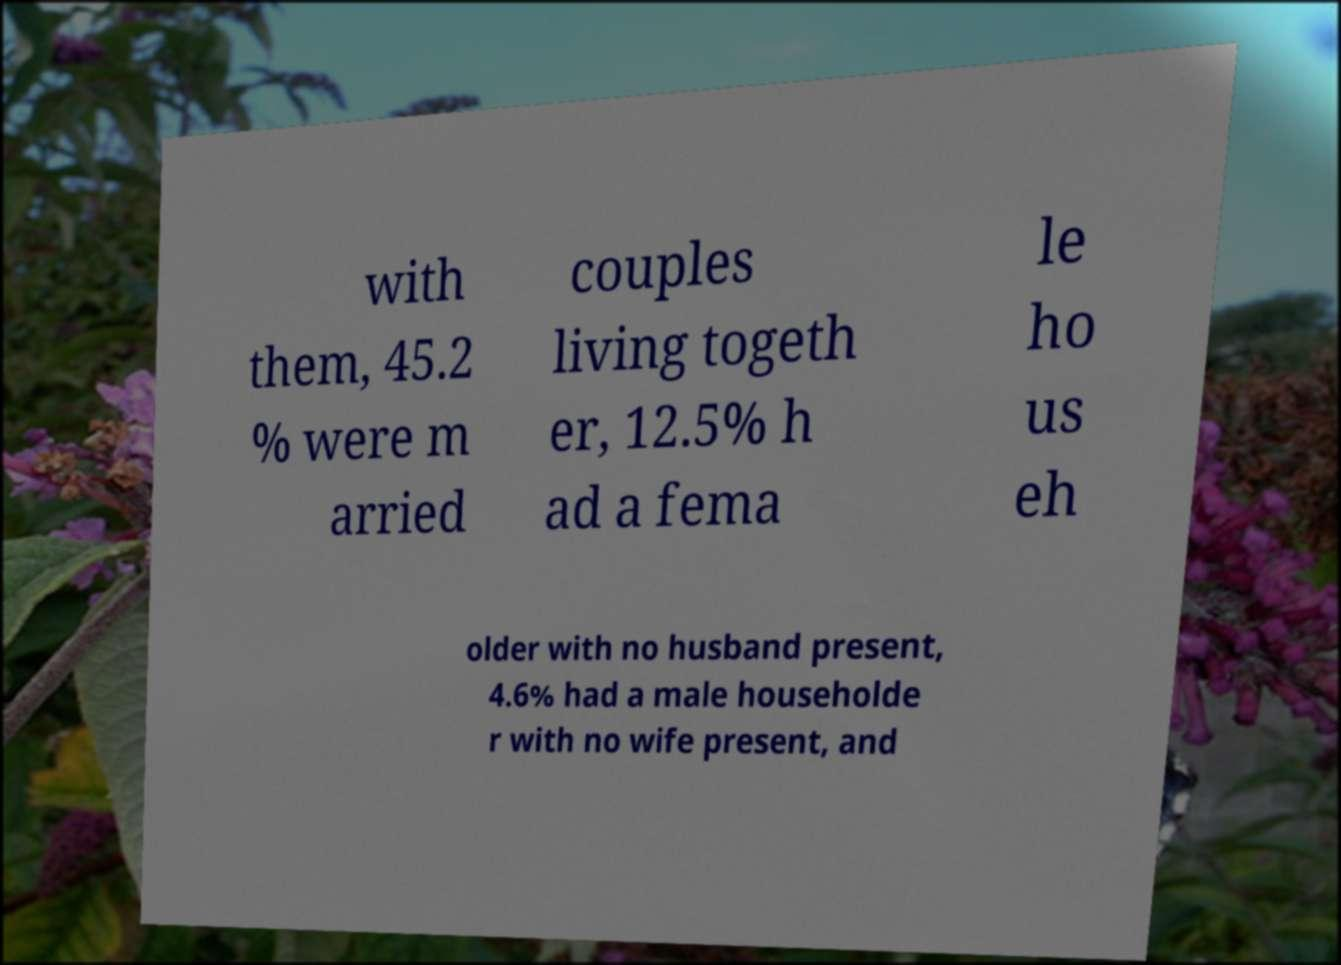What messages or text are displayed in this image? I need them in a readable, typed format. with them, 45.2 % were m arried couples living togeth er, 12.5% h ad a fema le ho us eh older with no husband present, 4.6% had a male householde r with no wife present, and 